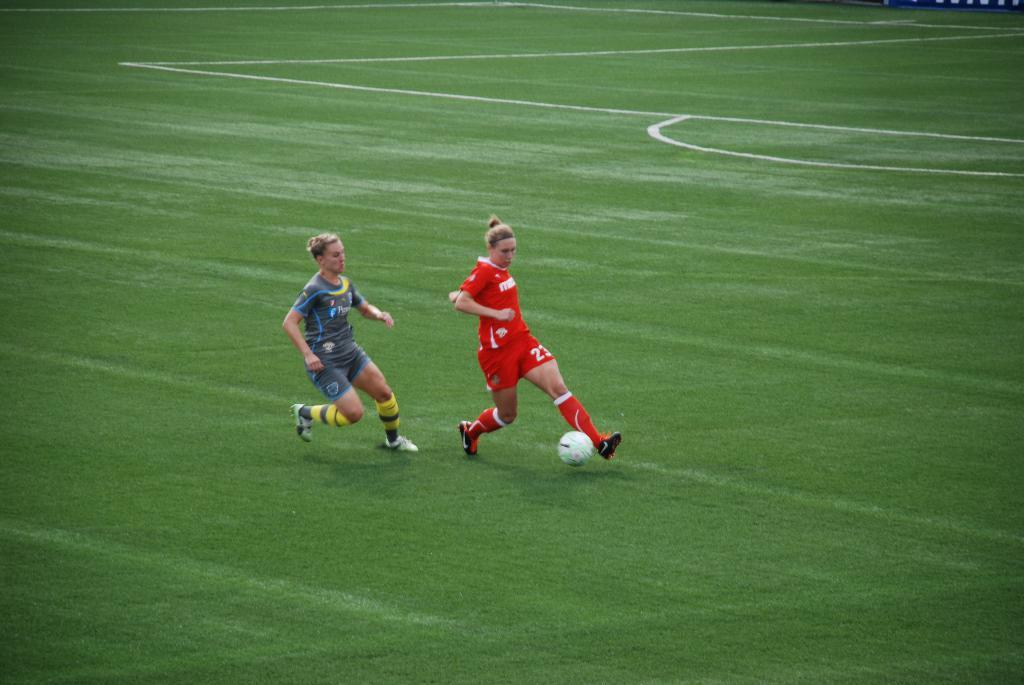<image>
Write a terse but informative summary of the picture. two women soccer players on the field, one has a red shirt # 23 and the other has a light blue. 